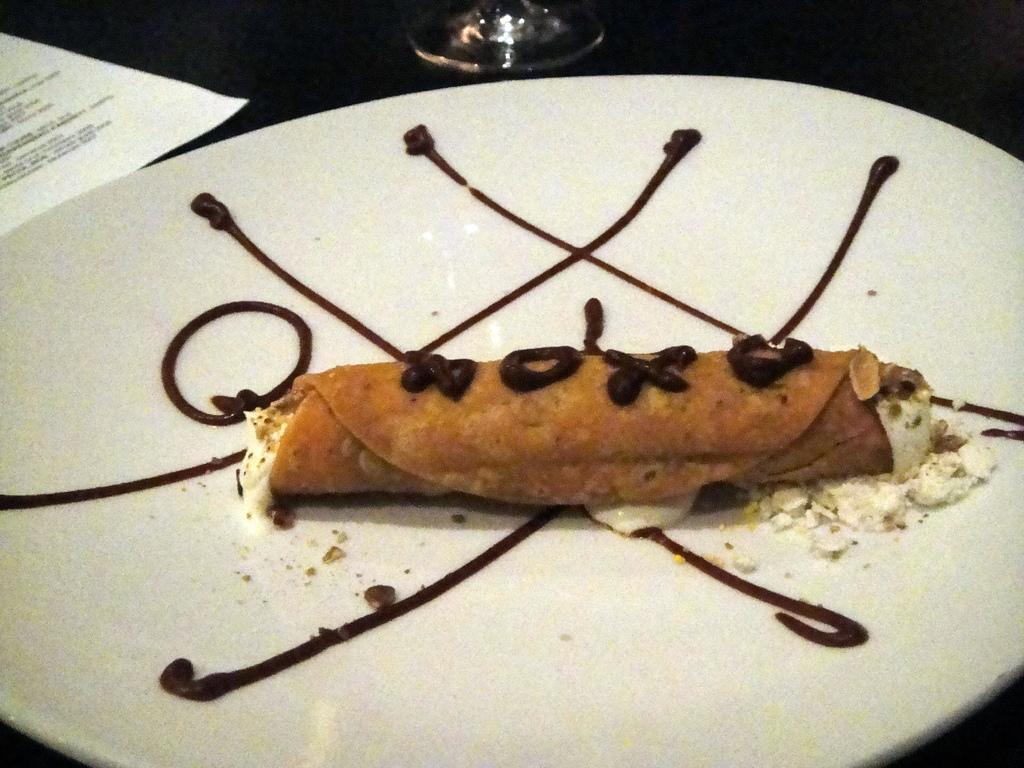How would you summarize this image in a sentence or two? This image consists of a food kept on a plate. The plate is kept on a table. On the left, there is a paper. In the front, there is a glass. 